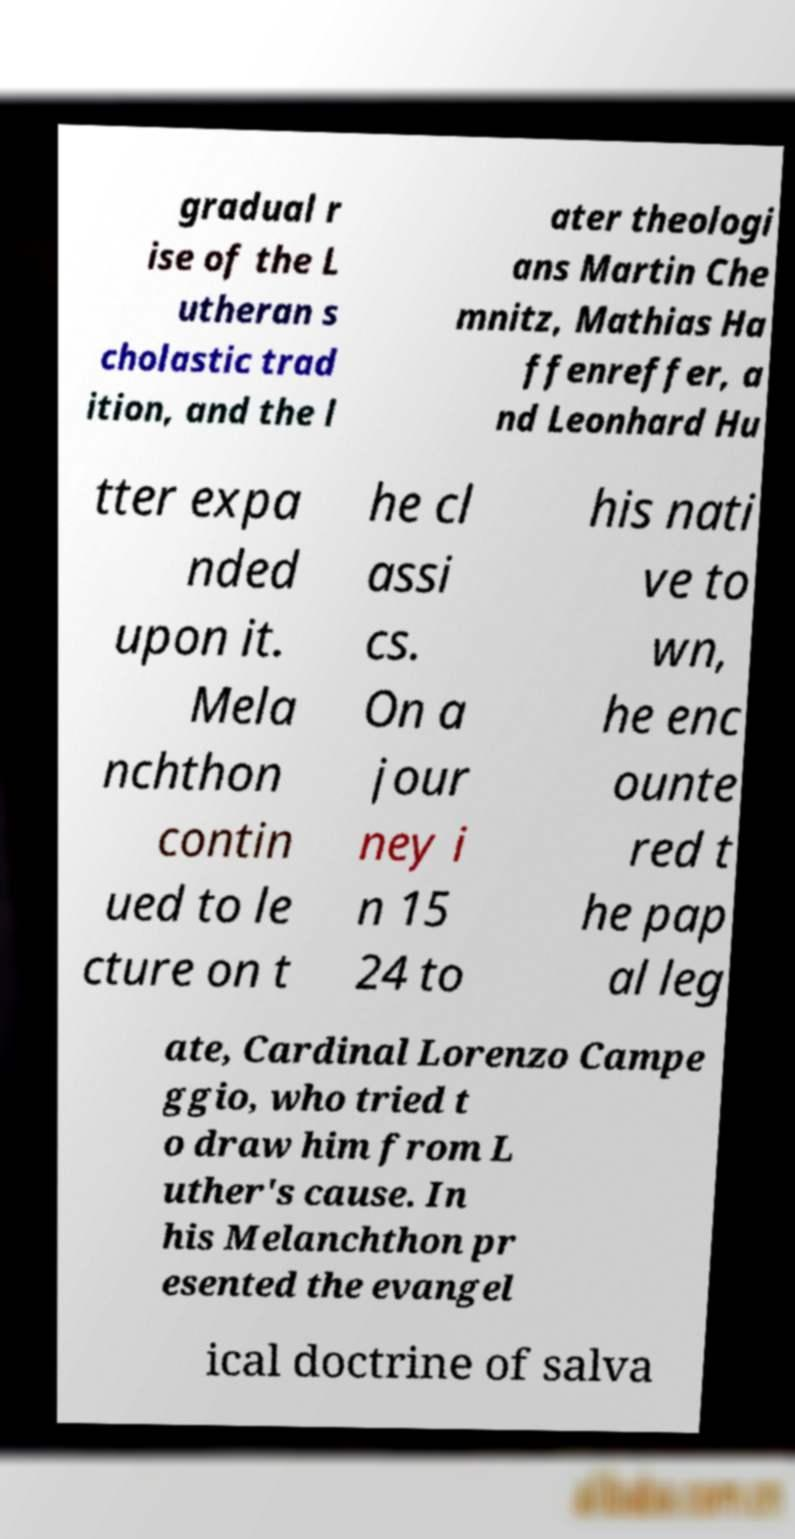Could you assist in decoding the text presented in this image and type it out clearly? gradual r ise of the L utheran s cholastic trad ition, and the l ater theologi ans Martin Che mnitz, Mathias Ha ffenreffer, a nd Leonhard Hu tter expa nded upon it. Mela nchthon contin ued to le cture on t he cl assi cs. On a jour ney i n 15 24 to his nati ve to wn, he enc ounte red t he pap al leg ate, Cardinal Lorenzo Campe ggio, who tried t o draw him from L uther's cause. In his Melanchthon pr esented the evangel ical doctrine of salva 